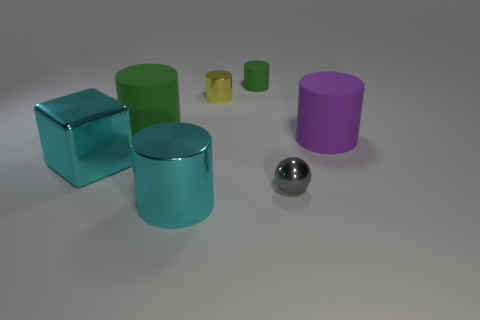What is the shape of the metal object that is both left of the small yellow metal thing and behind the cyan metallic cylinder?
Your answer should be compact. Cube. Is there a gray sphere made of the same material as the cube?
Keep it short and to the point. Yes. What material is the big cylinder that is the same color as the large cube?
Give a very brief answer. Metal. Do the large cylinder that is in front of the gray metallic ball and the big object that is behind the purple cylinder have the same material?
Your answer should be very brief. No. Is the number of yellow cylinders greater than the number of tiny cylinders?
Provide a short and direct response. No. What is the color of the big matte object that is on the right side of the green cylinder that is on the left side of the cylinder in front of the big purple cylinder?
Ensure brevity in your answer.  Purple. Does the rubber cylinder to the left of the small rubber thing have the same color as the shiny object that is behind the large purple thing?
Your answer should be compact. No. There is a small yellow object behind the metallic block; how many green things are behind it?
Provide a short and direct response. 1. Are there any small purple matte balls?
Ensure brevity in your answer.  No. What number of other objects are there of the same color as the cube?
Your answer should be compact. 1. 